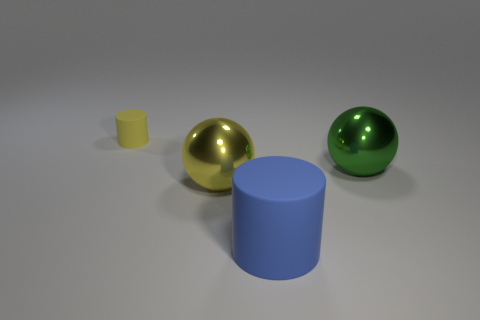Subtract all green spheres. How many spheres are left? 1 Add 1 yellow rubber things. How many objects exist? 5 Subtract 2 balls. How many balls are left? 0 Subtract all blue cylinders. How many yellow spheres are left? 1 Subtract all gray cylinders. Subtract all green blocks. How many cylinders are left? 2 Subtract all small yellow rubber things. Subtract all yellow things. How many objects are left? 1 Add 1 big yellow objects. How many big yellow objects are left? 2 Add 1 small red matte spheres. How many small red matte spheres exist? 1 Subtract 0 red blocks. How many objects are left? 4 